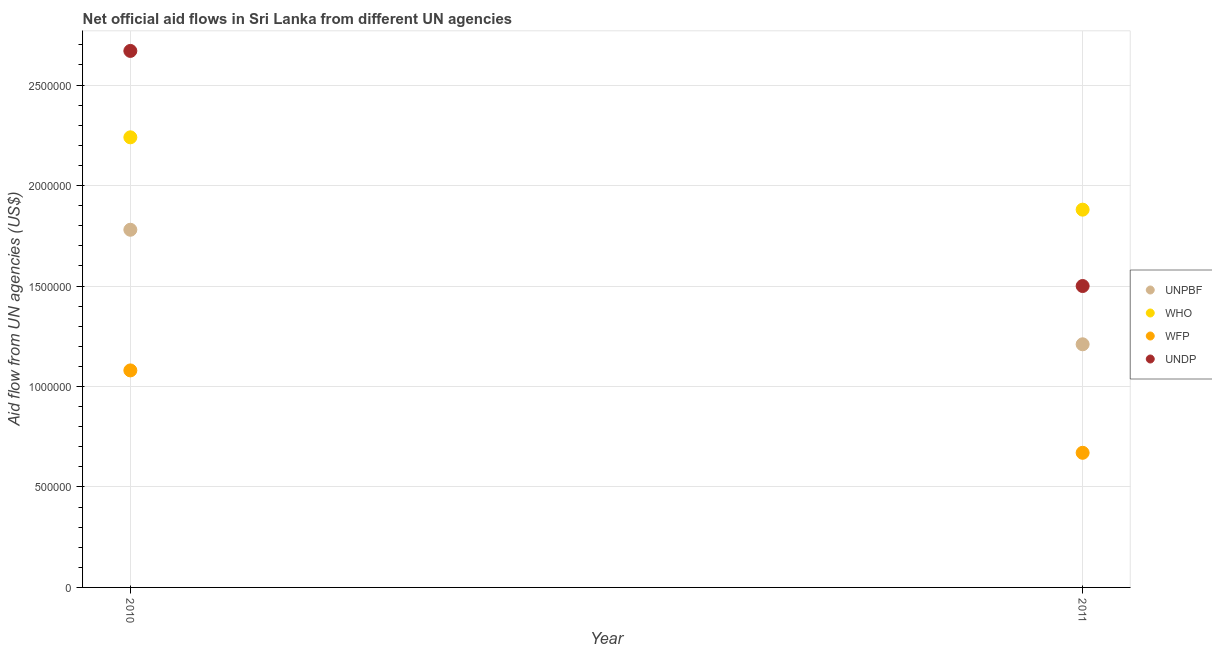How many different coloured dotlines are there?
Your answer should be very brief. 4. Is the number of dotlines equal to the number of legend labels?
Provide a succinct answer. Yes. What is the amount of aid given by who in 2011?
Offer a terse response. 1.88e+06. Across all years, what is the maximum amount of aid given by unpbf?
Your answer should be compact. 1.78e+06. Across all years, what is the minimum amount of aid given by unpbf?
Offer a terse response. 1.21e+06. In which year was the amount of aid given by unpbf maximum?
Ensure brevity in your answer.  2010. In which year was the amount of aid given by undp minimum?
Offer a very short reply. 2011. What is the total amount of aid given by wfp in the graph?
Give a very brief answer. 1.75e+06. What is the difference between the amount of aid given by wfp in 2010 and that in 2011?
Give a very brief answer. 4.10e+05. What is the difference between the amount of aid given by who in 2011 and the amount of aid given by undp in 2010?
Keep it short and to the point. -7.90e+05. What is the average amount of aid given by who per year?
Offer a very short reply. 2.06e+06. In the year 2011, what is the difference between the amount of aid given by wfp and amount of aid given by unpbf?
Your answer should be very brief. -5.40e+05. What is the ratio of the amount of aid given by unpbf in 2010 to that in 2011?
Provide a succinct answer. 1.47. Is the amount of aid given by wfp in 2010 less than that in 2011?
Provide a short and direct response. No. In how many years, is the amount of aid given by who greater than the average amount of aid given by who taken over all years?
Offer a very short reply. 1. Is it the case that in every year, the sum of the amount of aid given by unpbf and amount of aid given by who is greater than the amount of aid given by wfp?
Ensure brevity in your answer.  Yes. Does the amount of aid given by unpbf monotonically increase over the years?
Provide a succinct answer. No. Is the amount of aid given by unpbf strictly greater than the amount of aid given by wfp over the years?
Offer a very short reply. Yes. What is the difference between two consecutive major ticks on the Y-axis?
Ensure brevity in your answer.  5.00e+05. Are the values on the major ticks of Y-axis written in scientific E-notation?
Your response must be concise. No. Does the graph contain grids?
Offer a terse response. Yes. Where does the legend appear in the graph?
Offer a very short reply. Center right. What is the title of the graph?
Offer a terse response. Net official aid flows in Sri Lanka from different UN agencies. Does "Portugal" appear as one of the legend labels in the graph?
Offer a very short reply. No. What is the label or title of the Y-axis?
Keep it short and to the point. Aid flow from UN agencies (US$). What is the Aid flow from UN agencies (US$) in UNPBF in 2010?
Your answer should be compact. 1.78e+06. What is the Aid flow from UN agencies (US$) of WHO in 2010?
Offer a very short reply. 2.24e+06. What is the Aid flow from UN agencies (US$) of WFP in 2010?
Your answer should be compact. 1.08e+06. What is the Aid flow from UN agencies (US$) of UNDP in 2010?
Keep it short and to the point. 2.67e+06. What is the Aid flow from UN agencies (US$) in UNPBF in 2011?
Your answer should be compact. 1.21e+06. What is the Aid flow from UN agencies (US$) of WHO in 2011?
Your response must be concise. 1.88e+06. What is the Aid flow from UN agencies (US$) of WFP in 2011?
Your response must be concise. 6.70e+05. What is the Aid flow from UN agencies (US$) in UNDP in 2011?
Offer a very short reply. 1.50e+06. Across all years, what is the maximum Aid flow from UN agencies (US$) in UNPBF?
Your response must be concise. 1.78e+06. Across all years, what is the maximum Aid flow from UN agencies (US$) in WHO?
Make the answer very short. 2.24e+06. Across all years, what is the maximum Aid flow from UN agencies (US$) of WFP?
Ensure brevity in your answer.  1.08e+06. Across all years, what is the maximum Aid flow from UN agencies (US$) in UNDP?
Provide a short and direct response. 2.67e+06. Across all years, what is the minimum Aid flow from UN agencies (US$) in UNPBF?
Offer a very short reply. 1.21e+06. Across all years, what is the minimum Aid flow from UN agencies (US$) in WHO?
Offer a terse response. 1.88e+06. Across all years, what is the minimum Aid flow from UN agencies (US$) in WFP?
Your answer should be very brief. 6.70e+05. Across all years, what is the minimum Aid flow from UN agencies (US$) of UNDP?
Provide a succinct answer. 1.50e+06. What is the total Aid flow from UN agencies (US$) of UNPBF in the graph?
Your answer should be very brief. 2.99e+06. What is the total Aid flow from UN agencies (US$) in WHO in the graph?
Offer a terse response. 4.12e+06. What is the total Aid flow from UN agencies (US$) in WFP in the graph?
Make the answer very short. 1.75e+06. What is the total Aid flow from UN agencies (US$) in UNDP in the graph?
Offer a terse response. 4.17e+06. What is the difference between the Aid flow from UN agencies (US$) in UNPBF in 2010 and that in 2011?
Provide a short and direct response. 5.70e+05. What is the difference between the Aid flow from UN agencies (US$) in WHO in 2010 and that in 2011?
Your answer should be compact. 3.60e+05. What is the difference between the Aid flow from UN agencies (US$) in UNDP in 2010 and that in 2011?
Offer a very short reply. 1.17e+06. What is the difference between the Aid flow from UN agencies (US$) of UNPBF in 2010 and the Aid flow from UN agencies (US$) of WHO in 2011?
Keep it short and to the point. -1.00e+05. What is the difference between the Aid flow from UN agencies (US$) in UNPBF in 2010 and the Aid flow from UN agencies (US$) in WFP in 2011?
Ensure brevity in your answer.  1.11e+06. What is the difference between the Aid flow from UN agencies (US$) of WHO in 2010 and the Aid flow from UN agencies (US$) of WFP in 2011?
Offer a terse response. 1.57e+06. What is the difference between the Aid flow from UN agencies (US$) in WHO in 2010 and the Aid flow from UN agencies (US$) in UNDP in 2011?
Give a very brief answer. 7.40e+05. What is the difference between the Aid flow from UN agencies (US$) of WFP in 2010 and the Aid flow from UN agencies (US$) of UNDP in 2011?
Provide a short and direct response. -4.20e+05. What is the average Aid flow from UN agencies (US$) of UNPBF per year?
Provide a short and direct response. 1.50e+06. What is the average Aid flow from UN agencies (US$) in WHO per year?
Offer a very short reply. 2.06e+06. What is the average Aid flow from UN agencies (US$) in WFP per year?
Offer a very short reply. 8.75e+05. What is the average Aid flow from UN agencies (US$) in UNDP per year?
Your answer should be very brief. 2.08e+06. In the year 2010, what is the difference between the Aid flow from UN agencies (US$) of UNPBF and Aid flow from UN agencies (US$) of WHO?
Provide a short and direct response. -4.60e+05. In the year 2010, what is the difference between the Aid flow from UN agencies (US$) of UNPBF and Aid flow from UN agencies (US$) of UNDP?
Your response must be concise. -8.90e+05. In the year 2010, what is the difference between the Aid flow from UN agencies (US$) of WHO and Aid flow from UN agencies (US$) of WFP?
Your answer should be very brief. 1.16e+06. In the year 2010, what is the difference between the Aid flow from UN agencies (US$) of WHO and Aid flow from UN agencies (US$) of UNDP?
Keep it short and to the point. -4.30e+05. In the year 2010, what is the difference between the Aid flow from UN agencies (US$) of WFP and Aid flow from UN agencies (US$) of UNDP?
Keep it short and to the point. -1.59e+06. In the year 2011, what is the difference between the Aid flow from UN agencies (US$) in UNPBF and Aid flow from UN agencies (US$) in WHO?
Your answer should be very brief. -6.70e+05. In the year 2011, what is the difference between the Aid flow from UN agencies (US$) in UNPBF and Aid flow from UN agencies (US$) in WFP?
Provide a succinct answer. 5.40e+05. In the year 2011, what is the difference between the Aid flow from UN agencies (US$) in UNPBF and Aid flow from UN agencies (US$) in UNDP?
Your response must be concise. -2.90e+05. In the year 2011, what is the difference between the Aid flow from UN agencies (US$) in WHO and Aid flow from UN agencies (US$) in WFP?
Make the answer very short. 1.21e+06. In the year 2011, what is the difference between the Aid flow from UN agencies (US$) of WFP and Aid flow from UN agencies (US$) of UNDP?
Offer a very short reply. -8.30e+05. What is the ratio of the Aid flow from UN agencies (US$) in UNPBF in 2010 to that in 2011?
Offer a terse response. 1.47. What is the ratio of the Aid flow from UN agencies (US$) in WHO in 2010 to that in 2011?
Ensure brevity in your answer.  1.19. What is the ratio of the Aid flow from UN agencies (US$) of WFP in 2010 to that in 2011?
Keep it short and to the point. 1.61. What is the ratio of the Aid flow from UN agencies (US$) in UNDP in 2010 to that in 2011?
Give a very brief answer. 1.78. What is the difference between the highest and the second highest Aid flow from UN agencies (US$) of UNPBF?
Keep it short and to the point. 5.70e+05. What is the difference between the highest and the second highest Aid flow from UN agencies (US$) of WFP?
Ensure brevity in your answer.  4.10e+05. What is the difference between the highest and the second highest Aid flow from UN agencies (US$) of UNDP?
Make the answer very short. 1.17e+06. What is the difference between the highest and the lowest Aid flow from UN agencies (US$) of UNPBF?
Your response must be concise. 5.70e+05. What is the difference between the highest and the lowest Aid flow from UN agencies (US$) of WHO?
Your answer should be very brief. 3.60e+05. What is the difference between the highest and the lowest Aid flow from UN agencies (US$) in WFP?
Provide a succinct answer. 4.10e+05. What is the difference between the highest and the lowest Aid flow from UN agencies (US$) of UNDP?
Your response must be concise. 1.17e+06. 